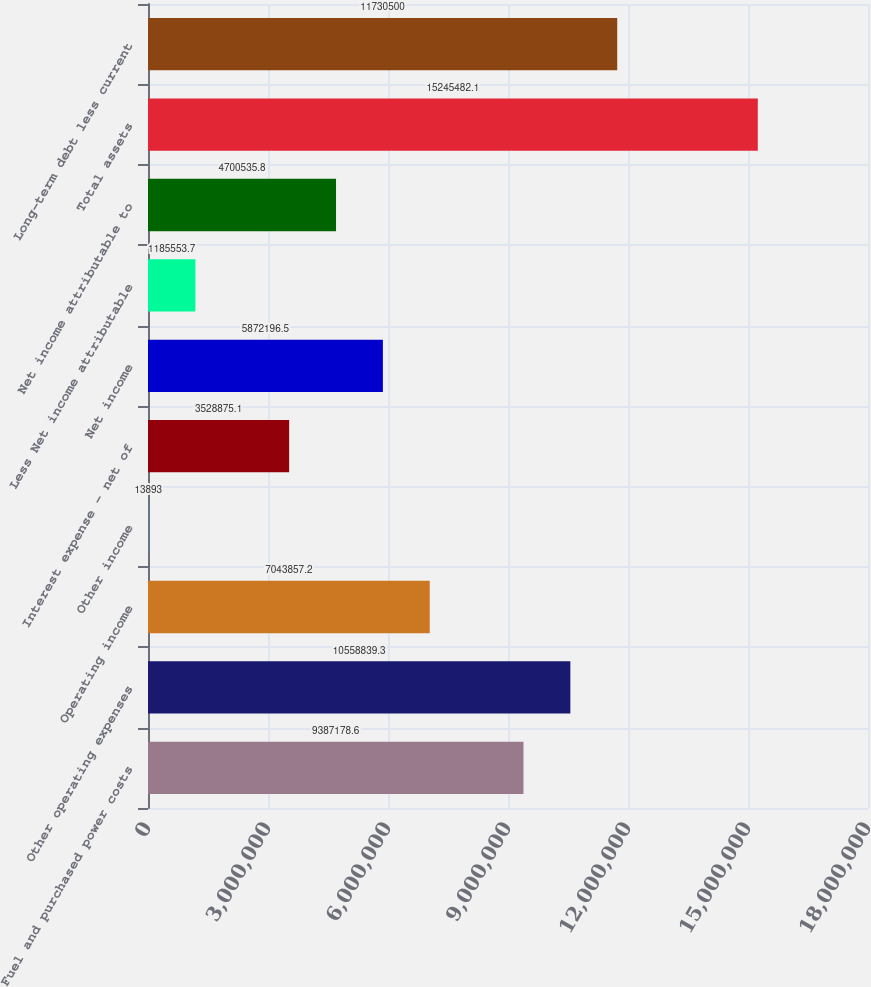<chart> <loc_0><loc_0><loc_500><loc_500><bar_chart><fcel>Fuel and purchased power costs<fcel>Other operating expenses<fcel>Operating income<fcel>Other income<fcel>Interest expense - net of<fcel>Net income<fcel>Less Net income attributable<fcel>Net income attributable to<fcel>Total assets<fcel>Long-term debt less current<nl><fcel>9.38718e+06<fcel>1.05588e+07<fcel>7.04386e+06<fcel>13893<fcel>3.52888e+06<fcel>5.8722e+06<fcel>1.18555e+06<fcel>4.70054e+06<fcel>1.52455e+07<fcel>1.17305e+07<nl></chart> 